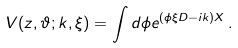Convert formula to latex. <formula><loc_0><loc_0><loc_500><loc_500>V ( z , \vartheta ; k , \xi ) = \int d \phi e ^ { ( \phi \xi D - i k ) X } \, .</formula> 